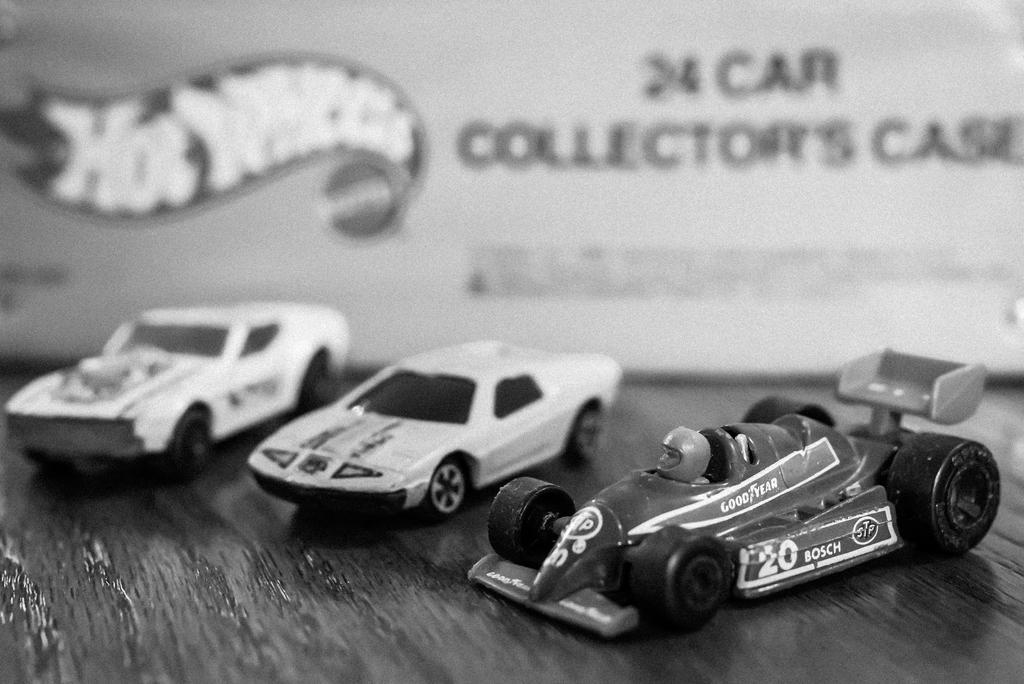What is the color scheme of the image? The image is black and white. What can be seen on the floor in the image? There are toys on the floor in the image. What type of pie is being served in the image? There is no pie present in the image; it is a black and white image featuring toys on the floor. 